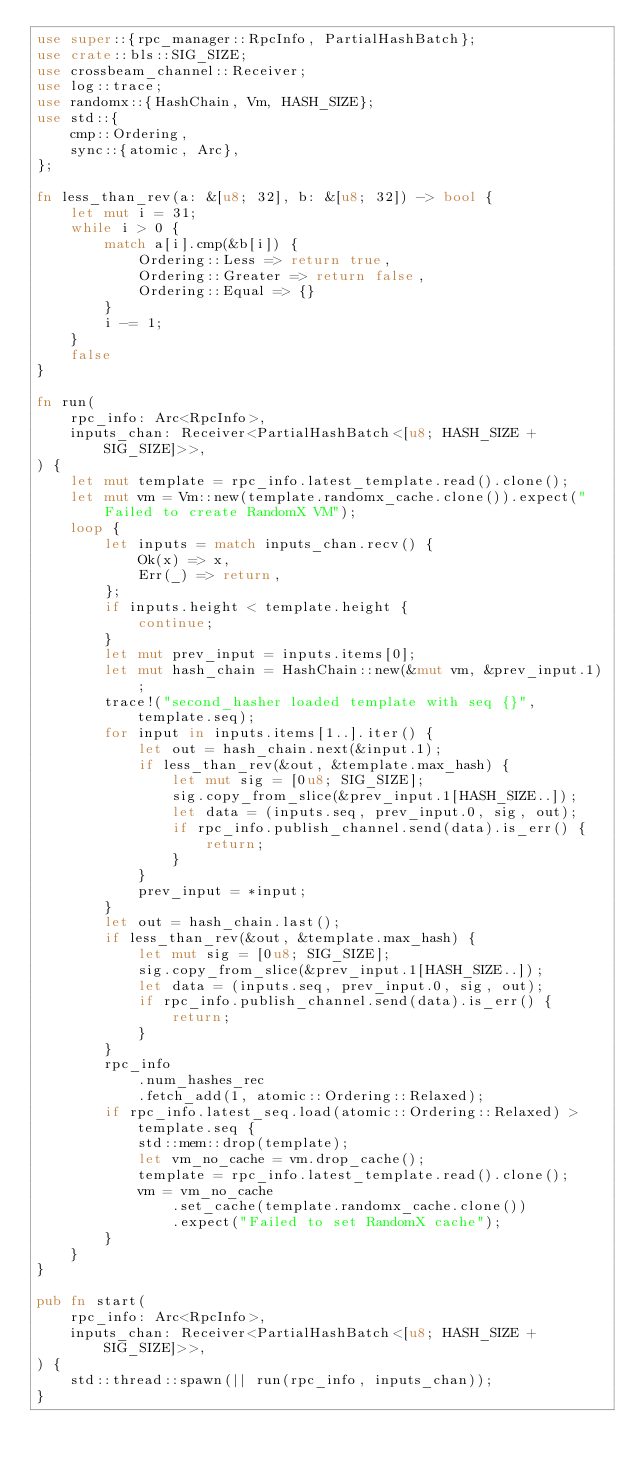Convert code to text. <code><loc_0><loc_0><loc_500><loc_500><_Rust_>use super::{rpc_manager::RpcInfo, PartialHashBatch};
use crate::bls::SIG_SIZE;
use crossbeam_channel::Receiver;
use log::trace;
use randomx::{HashChain, Vm, HASH_SIZE};
use std::{
    cmp::Ordering,
    sync::{atomic, Arc},
};

fn less_than_rev(a: &[u8; 32], b: &[u8; 32]) -> bool {
    let mut i = 31;
    while i > 0 {
        match a[i].cmp(&b[i]) {
            Ordering::Less => return true,
            Ordering::Greater => return false,
            Ordering::Equal => {}
        }
        i -= 1;
    }
    false
}

fn run(
    rpc_info: Arc<RpcInfo>,
    inputs_chan: Receiver<PartialHashBatch<[u8; HASH_SIZE + SIG_SIZE]>>,
) {
    let mut template = rpc_info.latest_template.read().clone();
    let mut vm = Vm::new(template.randomx_cache.clone()).expect("Failed to create RandomX VM");
    loop {
        let inputs = match inputs_chan.recv() {
            Ok(x) => x,
            Err(_) => return,
        };
        if inputs.height < template.height {
            continue;
        }
        let mut prev_input = inputs.items[0];
        let mut hash_chain = HashChain::new(&mut vm, &prev_input.1);
        trace!("second_hasher loaded template with seq {}", template.seq);
        for input in inputs.items[1..].iter() {
            let out = hash_chain.next(&input.1);
            if less_than_rev(&out, &template.max_hash) {
                let mut sig = [0u8; SIG_SIZE];
                sig.copy_from_slice(&prev_input.1[HASH_SIZE..]);
                let data = (inputs.seq, prev_input.0, sig, out);
                if rpc_info.publish_channel.send(data).is_err() {
                    return;
                }
            }
            prev_input = *input;
        }
        let out = hash_chain.last();
        if less_than_rev(&out, &template.max_hash) {
            let mut sig = [0u8; SIG_SIZE];
            sig.copy_from_slice(&prev_input.1[HASH_SIZE..]);
            let data = (inputs.seq, prev_input.0, sig, out);
            if rpc_info.publish_channel.send(data).is_err() {
                return;
            }
        }
        rpc_info
            .num_hashes_rec
            .fetch_add(1, atomic::Ordering::Relaxed);
        if rpc_info.latest_seq.load(atomic::Ordering::Relaxed) > template.seq {
            std::mem::drop(template);
            let vm_no_cache = vm.drop_cache();
            template = rpc_info.latest_template.read().clone();
            vm = vm_no_cache
                .set_cache(template.randomx_cache.clone())
                .expect("Failed to set RandomX cache");
        }
    }
}

pub fn start(
    rpc_info: Arc<RpcInfo>,
    inputs_chan: Receiver<PartialHashBatch<[u8; HASH_SIZE + SIG_SIZE]>>,
) {
    std::thread::spawn(|| run(rpc_info, inputs_chan));
}
</code> 